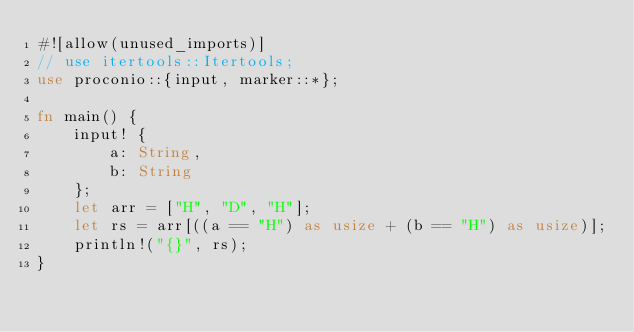Convert code to text. <code><loc_0><loc_0><loc_500><loc_500><_Rust_>#![allow(unused_imports)]
// use itertools::Itertools;
use proconio::{input, marker::*};

fn main() {
    input! {
        a: String,
        b: String
    };
    let arr = ["H", "D", "H"];
    let rs = arr[((a == "H") as usize + (b == "H") as usize)];
    println!("{}", rs);
}
</code> 